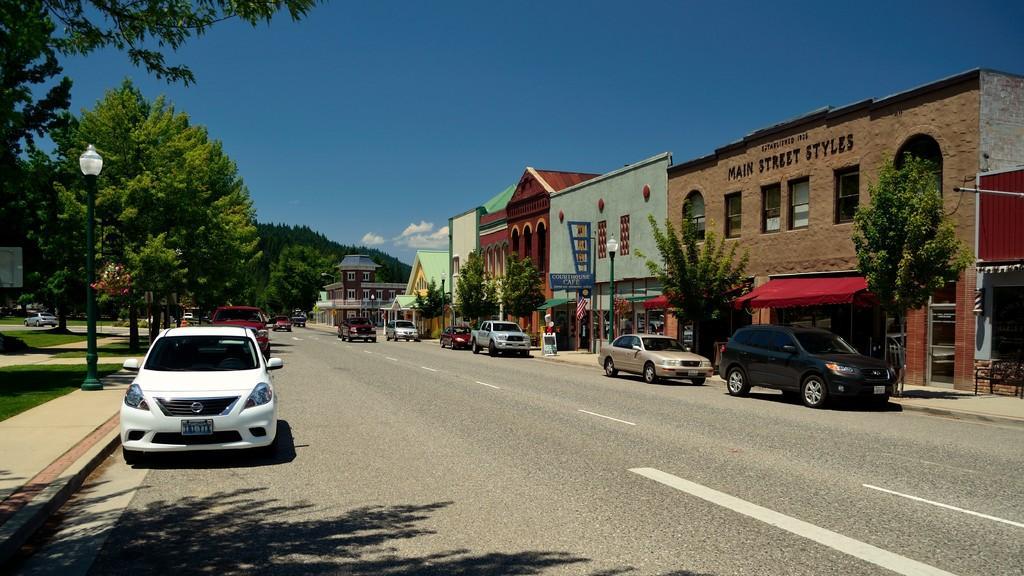Could you give a brief overview of what you see in this image? In this image I can see few vehicles on the road. I can see few trees. There are few buildings. At the top I can see clouds in the sky. 